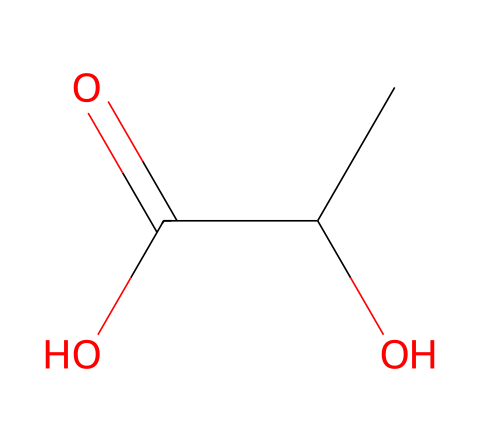What is the molecular formula of lactic acid? The SMILES representation of lactic acid is CC(O)C(=O)O, which shows that it consists of two carbon atoms (C), four hydrogen atoms (H), and three oxygen atoms (O). Therefore, the molecular formula is C3H6O3.
Answer: C3H6O3 How many chiral centers are present in lactic acid? By examining the SMILES, we see that there is a carbon atom attached to four different groups (the hydroxyl group, the methyl group, the carboxyl group, and the hydrogen atom). This characteristic indicates that there is one chiral center in lactic acid.
Answer: one What type of functional groups are present in lactic acid? Analyzing the SMILES, we identify the -OH (hydroxyl) group and the -COOH (carboxylic acid) group. These groups classify lactic acid as an alcohol (due to the -OH) and an acid (due to the -COOH).
Answer: alcohol and carboxylic acid What is the significance of the chiral nature of lactic acid in biodegradable plastics? The chiral nature of lactic acid allows for the formation of different isomers. In biodegradable plastics, the L-lactic acid form is typically used for its properties, leading to enhanced solubility and degradation, which are critical for environmental sustainability.
Answer: biodegradability How many total atoms are in lactic acid? The molecular structure from the SMILES tells us there are 3 carbon atoms, 6 hydrogen atoms, and 3 oxygen atoms, which sums to a total of 12 atoms (3 + 6 + 3 = 12).
Answer: 12 What is the stereochemical configuration of lactic acid? The presence of a chiral center generally implies that lactic acid can exist as two enantiomers (D and L forms). The L-form is commonly used in applications such as biodegradable plastics.
Answer: L-form 